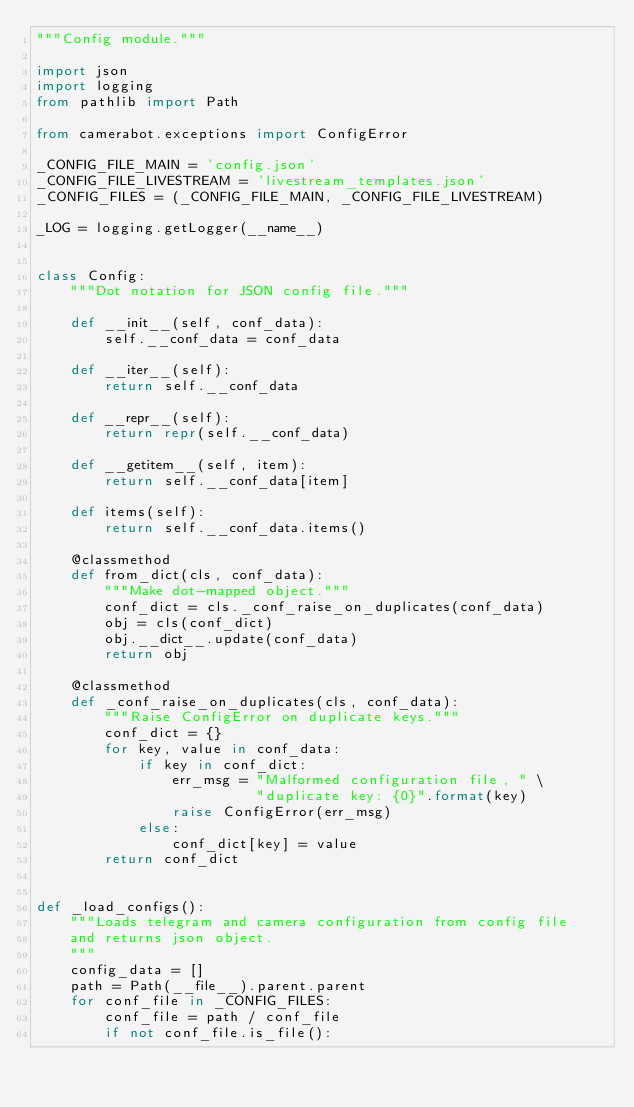<code> <loc_0><loc_0><loc_500><loc_500><_Python_>"""Config module."""

import json
import logging
from pathlib import Path

from camerabot.exceptions import ConfigError

_CONFIG_FILE_MAIN = 'config.json'
_CONFIG_FILE_LIVESTREAM = 'livestream_templates.json'
_CONFIG_FILES = (_CONFIG_FILE_MAIN, _CONFIG_FILE_LIVESTREAM)

_LOG = logging.getLogger(__name__)


class Config:
    """Dot notation for JSON config file."""

    def __init__(self, conf_data):
        self.__conf_data = conf_data

    def __iter__(self):
        return self.__conf_data

    def __repr__(self):
        return repr(self.__conf_data)

    def __getitem__(self, item):
        return self.__conf_data[item]

    def items(self):
        return self.__conf_data.items()

    @classmethod
    def from_dict(cls, conf_data):
        """Make dot-mapped object."""
        conf_dict = cls._conf_raise_on_duplicates(conf_data)
        obj = cls(conf_dict)
        obj.__dict__.update(conf_data)
        return obj

    @classmethod
    def _conf_raise_on_duplicates(cls, conf_data):
        """Raise ConfigError on duplicate keys."""
        conf_dict = {}
        for key, value in conf_data:
            if key in conf_dict:
                err_msg = "Malformed configuration file, " \
                          "duplicate key: {0}".format(key)
                raise ConfigError(err_msg)
            else:
                conf_dict[key] = value
        return conf_dict


def _load_configs():
    """Loads telegram and camera configuration from config file
    and returns json object.
    """
    config_data = []
    path = Path(__file__).parent.parent
    for conf_file in _CONFIG_FILES:
        conf_file = path / conf_file
        if not conf_file.is_file():</code> 